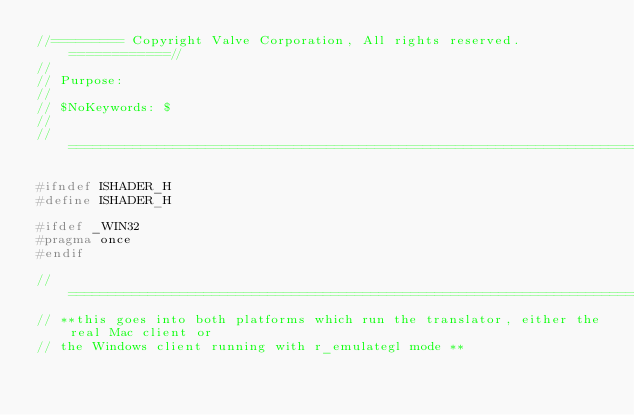<code> <loc_0><loc_0><loc_500><loc_500><_C_>//========= Copyright Valve Corporation, All rights reserved. ============//
//
// Purpose: 
//
// $NoKeywords: $
//
//=============================================================================//

#ifndef ISHADER_H
#define ISHADER_H

#ifdef _WIN32
#pragma once
#endif

//==================================================================================================
// **this goes into both platforms which run the translator, either the real Mac client or
// the Windows client running with r_emulategl mode **</code> 